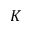Convert formula to latex. <formula><loc_0><loc_0><loc_500><loc_500>K</formula> 